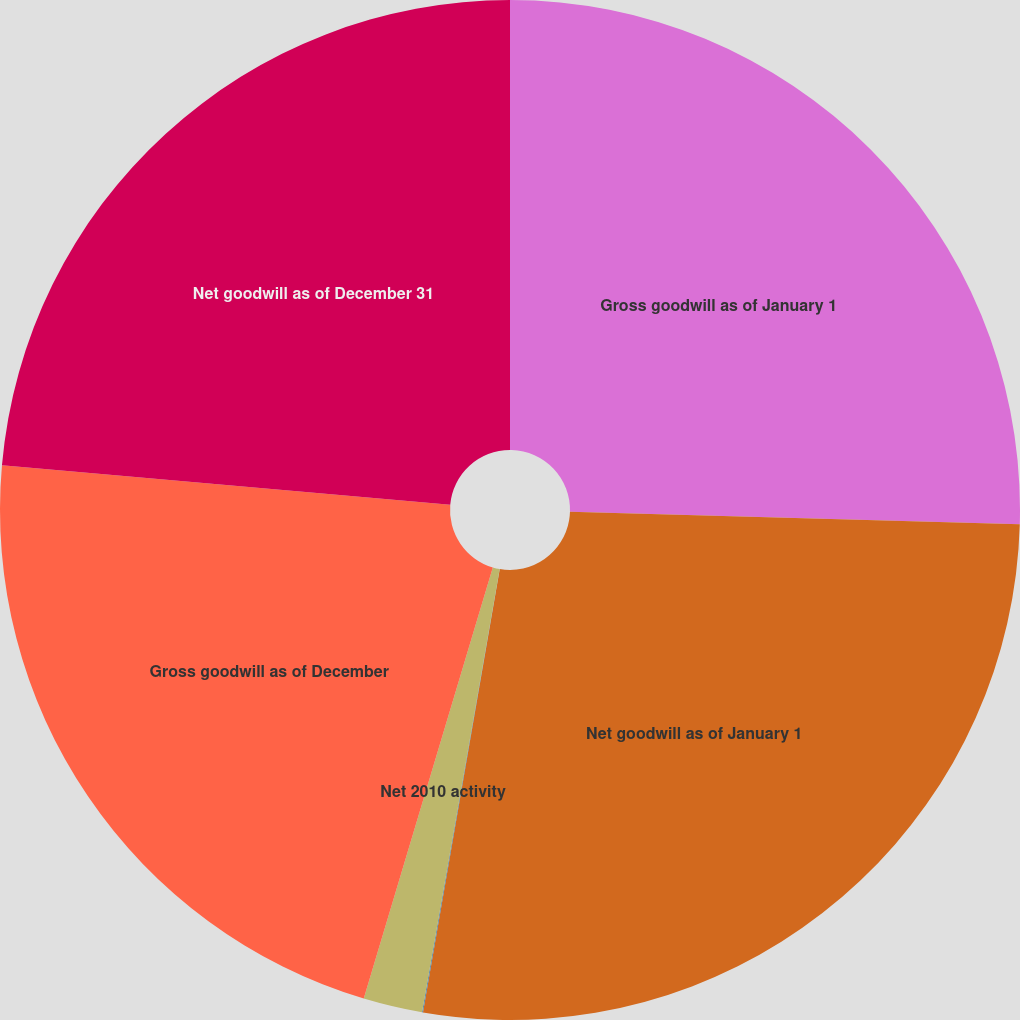Convert chart. <chart><loc_0><loc_0><loc_500><loc_500><pie_chart><fcel>Gross goodwill as of January 1<fcel>Net goodwill as of January 1<fcel>Foreign currency translation<fcel>Net 2010 activity<fcel>Gross goodwill as of December<fcel>Net goodwill as of December 31<nl><fcel>25.45%<fcel>27.29%<fcel>0.03%<fcel>1.87%<fcel>21.77%<fcel>23.61%<nl></chart> 